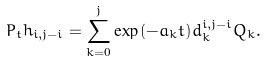<formula> <loc_0><loc_0><loc_500><loc_500>P _ { t } h _ { i , j - i } = \sum _ { k = 0 } ^ { j } \exp { ( - a _ { k } t ) } d _ { k } ^ { i , j - i } Q _ { k } .</formula> 